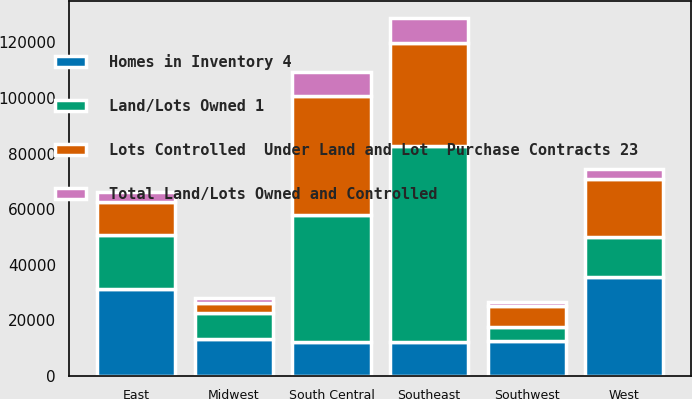Convert chart. <chart><loc_0><loc_0><loc_500><loc_500><stacked_bar_chart><ecel><fcel>East<fcel>Midwest<fcel>Southeast<fcel>South Central<fcel>Southwest<fcel>West<nl><fcel>Lots Controlled  Under Land and Lot  Purchase Contracts 23<fcel>11900<fcel>3800<fcel>37100<fcel>42900<fcel>7600<fcel>21000<nl><fcel>Land/Lots Owned 1<fcel>19400<fcel>9300<fcel>70400<fcel>45700<fcel>5000<fcel>14400<nl><fcel>Homes in Inventory 4<fcel>31300<fcel>13100<fcel>12250<fcel>12250<fcel>12600<fcel>35400<nl><fcel>Total Land/Lots Owned and Controlled<fcel>3700<fcel>1700<fcel>8900<fcel>8400<fcel>1400<fcel>3800<nl></chart> 